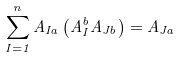Convert formula to latex. <formula><loc_0><loc_0><loc_500><loc_500>\sum _ { I = 1 } ^ { n } A _ { I a } \left ( A ^ { b } _ { I } A _ { J b } \right ) = A _ { J a }</formula> 